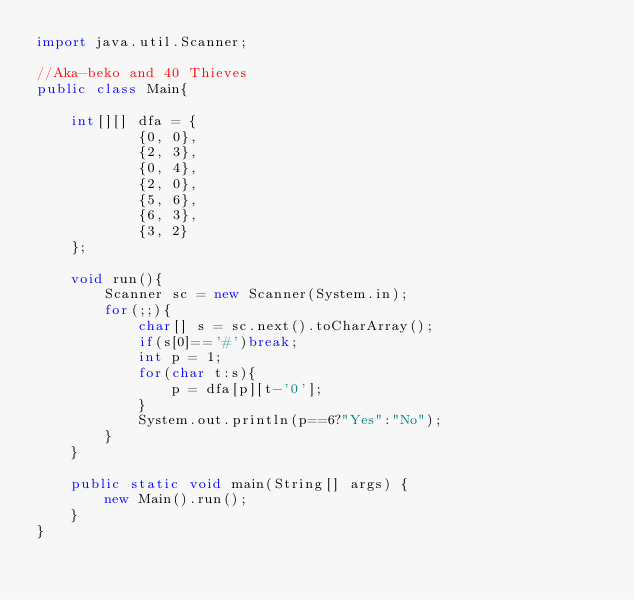<code> <loc_0><loc_0><loc_500><loc_500><_Java_>import java.util.Scanner;

//Aka-beko and 40 Thieves
public class Main{

	int[][] dfa = {
			{0, 0},
			{2, 3},
			{0, 4},
			{2, 0},
			{5, 6},
			{6, 3},
			{3, 2}
	};
	
	void run(){
		Scanner sc = new Scanner(System.in);
		for(;;){
			char[] s = sc.next().toCharArray();
			if(s[0]=='#')break;
			int p = 1;
			for(char t:s){
				p = dfa[p][t-'0'];
			}
			System.out.println(p==6?"Yes":"No");
		}
	}
	
	public static void main(String[] args) {
		new Main().run();
	}
}</code> 